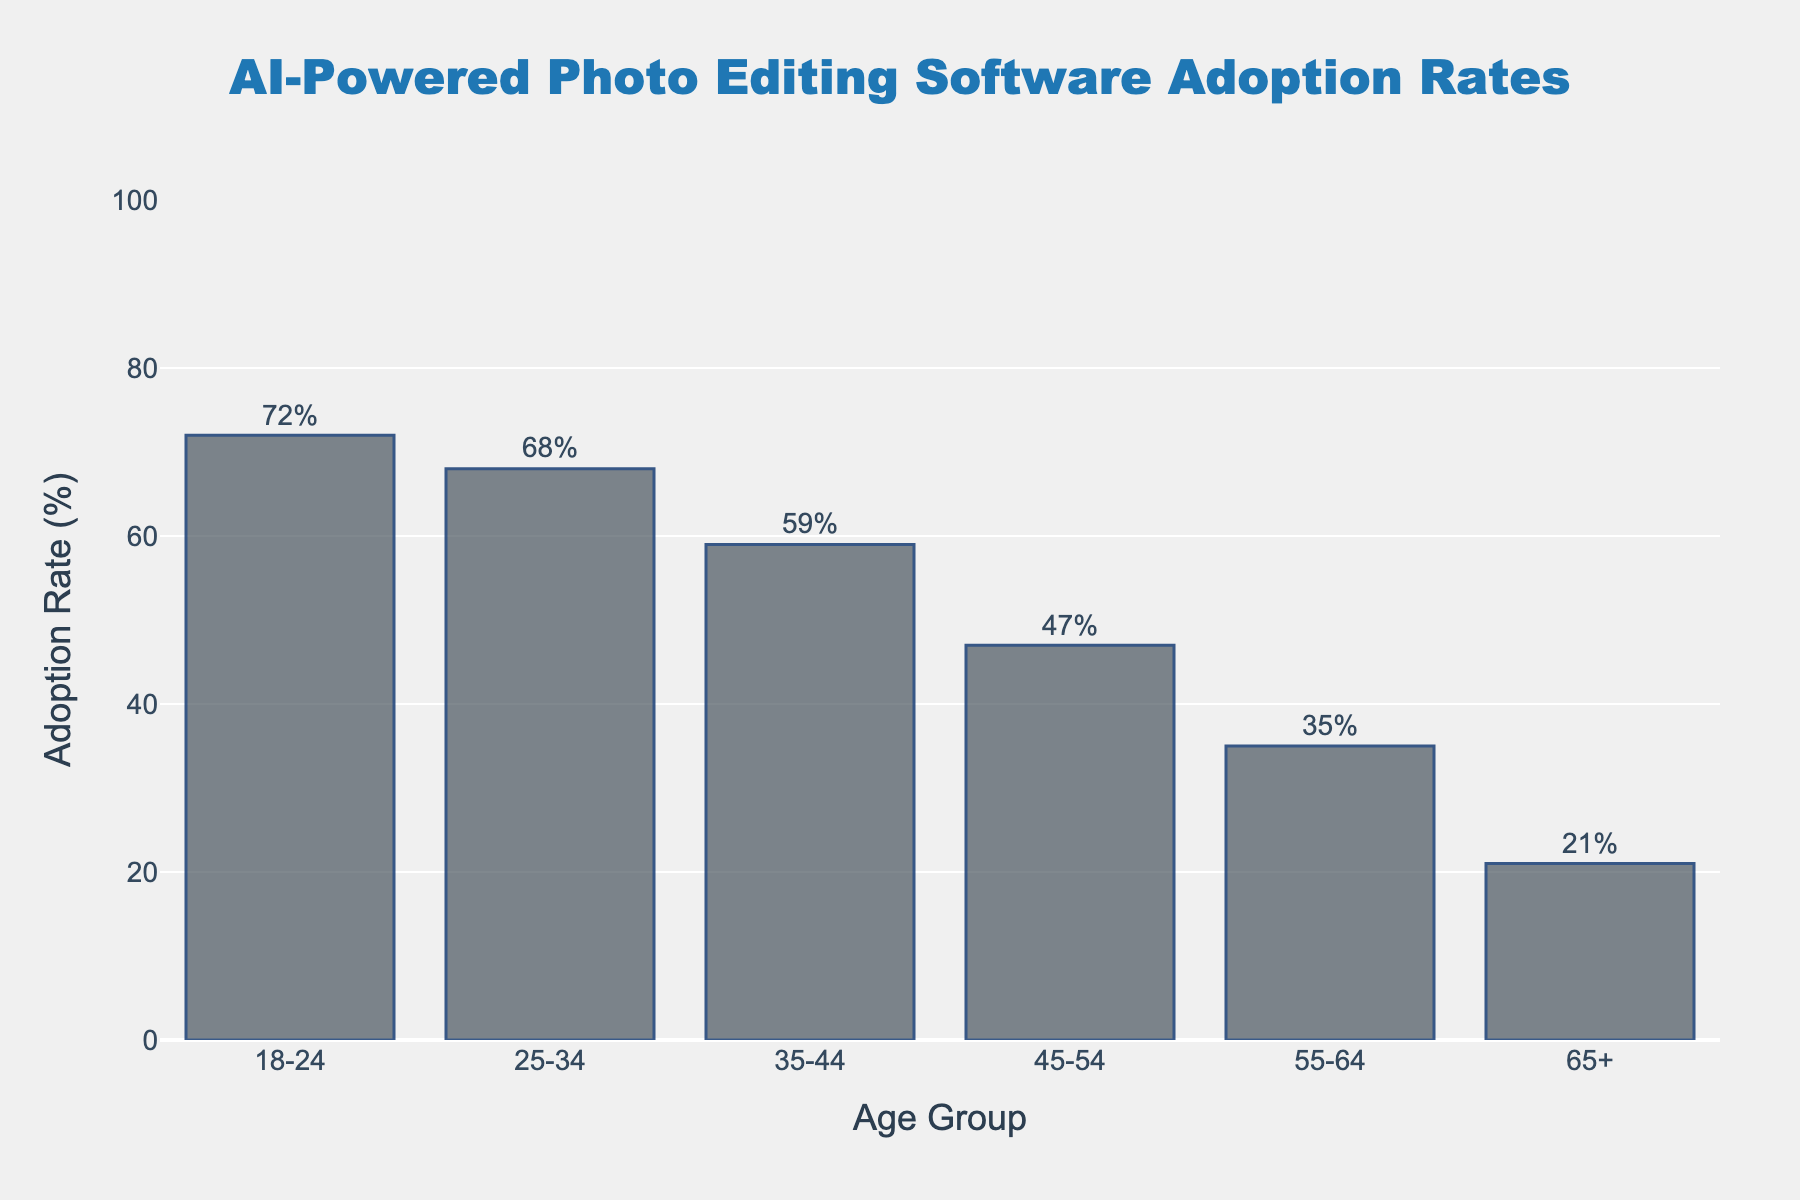What age group has the highest adoption rate of AI-powered photo editing software? The bar labelled '18-24' is the tallest, indicating the highest adoption rate among all age groups.
Answer: 18-24 What is the difference in adoption rates between the 18-24 and 65+ age groups? The adoption rate for 18-24 is 72%, and for 65+ it is 21%. The difference is calculated as 72% - 21% = 51%.
Answer: 51% Which age group has a lower adoption rate, 25-34 or 45-54? Comparing the heights of the bars for 25-34 and 45-54, the bar for 45-54 is shorter, indicating a lower adoption rate.
Answer: 45-54 What is the average adoption rate across all age groups? Sum all the adoption rates: 72 + 68 + 59 + 47 + 35 + 21 = 302. Then divide by the number of age groups, which is 6. The average is 302 / 6 ≈ 50.3%.
Answer: 50.3% What is the adoption rate for the age group with the shortest bar? The shortest bar corresponds to the 65+ age group, which has an adoption rate of 21%.
Answer: 21% How many age groups have an adoption rate above 50%? Identify the bars that exceed the 50% mark: 18-24 (72%), 25-34 (68%), and 35-44 (59%). This means 3 age groups have an adoption rate above 50%.
Answer: 3 What percentage of the total adoption rate does the 55-64 age group represent? The adoption rate for 55-64 is 35%. The total adoption rate is 302%. The percentage is (35 / 302) × 100 ≈ 11.6%.
Answer: 11.6% Is the adoption rate for the 45-54 age group more than twice that of the 65+ age group? The adoption rate for 45-54 is 47%, and for 65+ it is 21%. Double the 65+ rate is 42%. Since 47% > 42%, it is more than twice.
Answer: Yes 